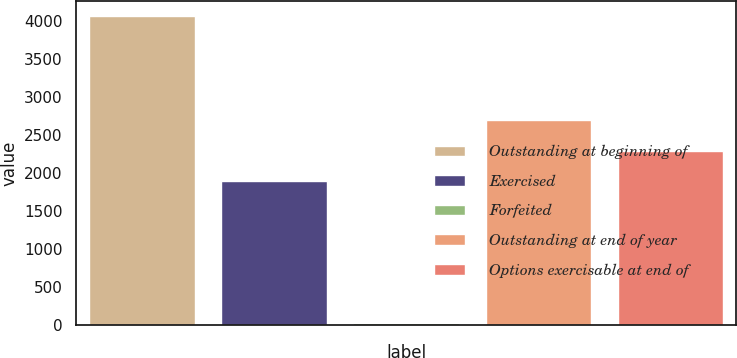<chart> <loc_0><loc_0><loc_500><loc_500><bar_chart><fcel>Outstanding at beginning of<fcel>Exercised<fcel>Forfeited<fcel>Outstanding at end of year<fcel>Options exercisable at end of<nl><fcel>4059<fcel>1890<fcel>31<fcel>2695.6<fcel>2292.8<nl></chart> 